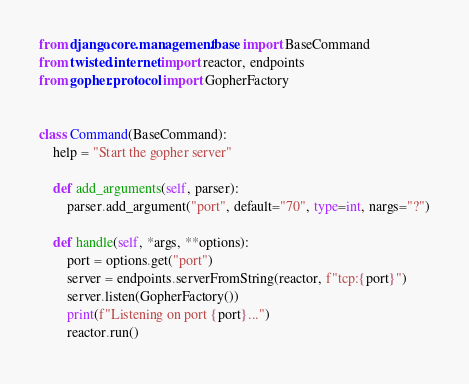<code> <loc_0><loc_0><loc_500><loc_500><_Python_>from django.core.management.base import BaseCommand
from twisted.internet import reactor, endpoints
from gopher.protocol import GopherFactory


class Command(BaseCommand):
    help = "Start the gopher server"

    def add_arguments(self, parser):
        parser.add_argument("port", default="70", type=int, nargs="?")

    def handle(self, *args, **options):
        port = options.get("port")
        server = endpoints.serverFromString(reactor, f"tcp:{port}")
        server.listen(GopherFactory())
        print(f"Listening on port {port}...")
        reactor.run()
</code> 